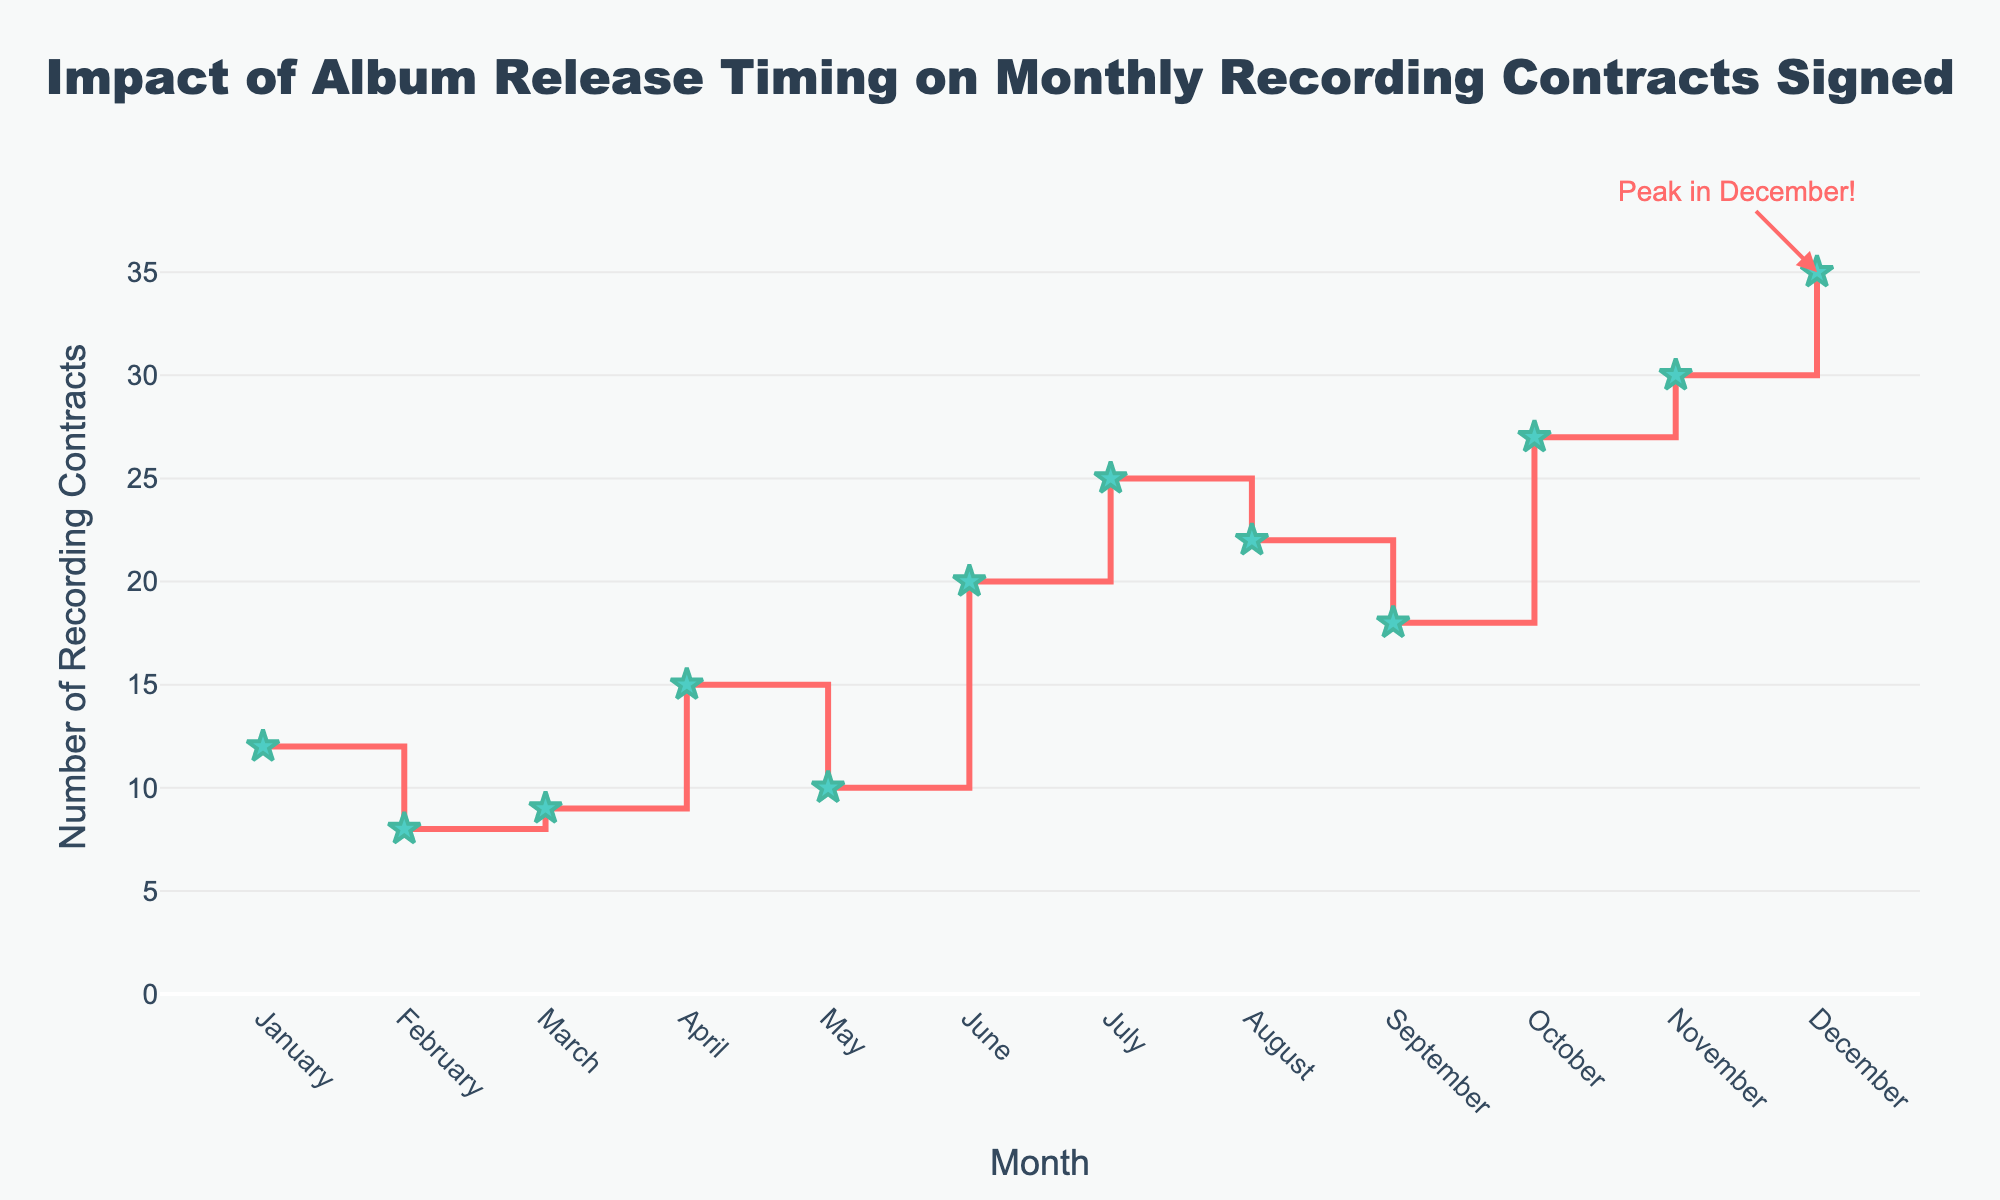What is the title of the plot? The title is located at the top of the plot, and it clearly states the main subject of the visualization. The title is formatted to be large and noticeable.
Answer: Impact of Album Release Timing on Monthly Recording Contracts Signed How many recording contracts were signed in March? Look for the data point corresponding to March on the x-axis and check the y-value indicated by that point.
Answer: 9 Which month has the highest number of recording contracts signed? Inspect the y-values across all months and find the peak. December has an annotated note indicating it's the peak.
Answer: December What is the range of the y-axis? Check the y-axis labels starting from the lowest to the highest value displayed. The range starts from a little above zero and goes up to slightly above the highest data point value.
Answer: 0 to 38.5 What are the colors of the markers and lines used in the plot? Observe the visual properties of the plot, noting the colors used for the lines and markers.
Answer: Markers are turquoise, and lines are reddish Which month has the lowest number of recording contracts signed? Identify the month corresponding to the minimum y-value.
Answer: February What is the total number of recording contracts signed in the first quarter of the year (January, February, and March)? Sum the number of contracts in January, February, and March: 12 (January) + 8 (February) + 9 (March).
Answer: 29 How does the number of recording contracts signed in October compare to those signed in November? Look at the y-values for October and November for a direct comparison. October has 27, and November has 30.
Answer: November has more contracts signed What is the average number of recording contracts signed per month? Calculate the sum of all monthly values and divide by 12. Sum is 231, so average = 231/12.
Answer: 19.25 During which month did the number of recording contracts increase the most compared to the previous month? Examine the changes in y-values month-to-month to find the largest increase. The increase from May (10) to June (20) is the largest.
Answer: June 